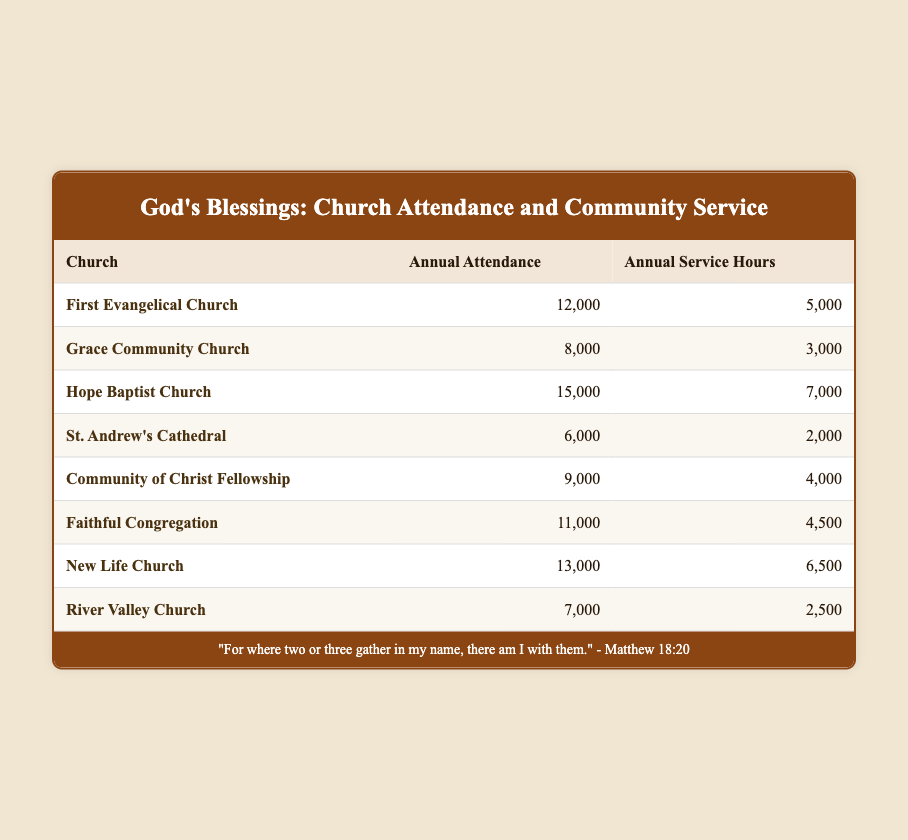What is the annual attendance of Grace Community Church? The table shows that the annual attendance for Grace Community Church is 8,000.
Answer: 8,000 Which church has the highest annual service hours? By comparing the service hours in the table, Hope Baptist Church has the highest with 7,000 hours.
Answer: 7,000 What is the difference in annual attendance between New Life Church and River Valley Church? New Life Church has an annual attendance of 13,000 and River Valley Church has 7,000. The difference is 13,000 - 7,000 = 6,000.
Answer: 6,000 Is it true that St. Andrew's Cathedral has more annual attendance than Faithful Congregation? St. Andrew's Cathedral has an attendance of 6,000 and Faithful Congregation has 11,000. Since 6,000 is less than 11,000, the statement is false.
Answer: No What is the average annual service hours of the churches listed? The total service hours from the table are 5,000 + 3,000 + 7,000 + 2,000 + 4,000 + 4,500 + 6,500 + 2,500 = 34,500. There are 8 churches, so the average is 34,500 / 8 = 4,312.5.
Answer: 4,312.5 Which church has the lowest annual attendance? Upon reviewing the table, St. Andrew's Cathedral has the lowest annual attendance at 6,000.
Answer: 6,000 If you combine the service hours of the two churches with the least annual attendance, what is the total? The two churches with the least attendance are St. Andrew's Cathedral (2,000 service hours) and River Valley Church (2,500 service hours). The total is 2,000 + 2,500 = 4,500.
Answer: 4,500 Is Faithful Congregation's annual service hours higher than those of Community of Christ Fellowship? Faithful Congregation has 4,500 service hours while Community of Christ Fellowship has 4,000. Since 4,500 is greater than 4,000, the statement is true.
Answer: Yes 